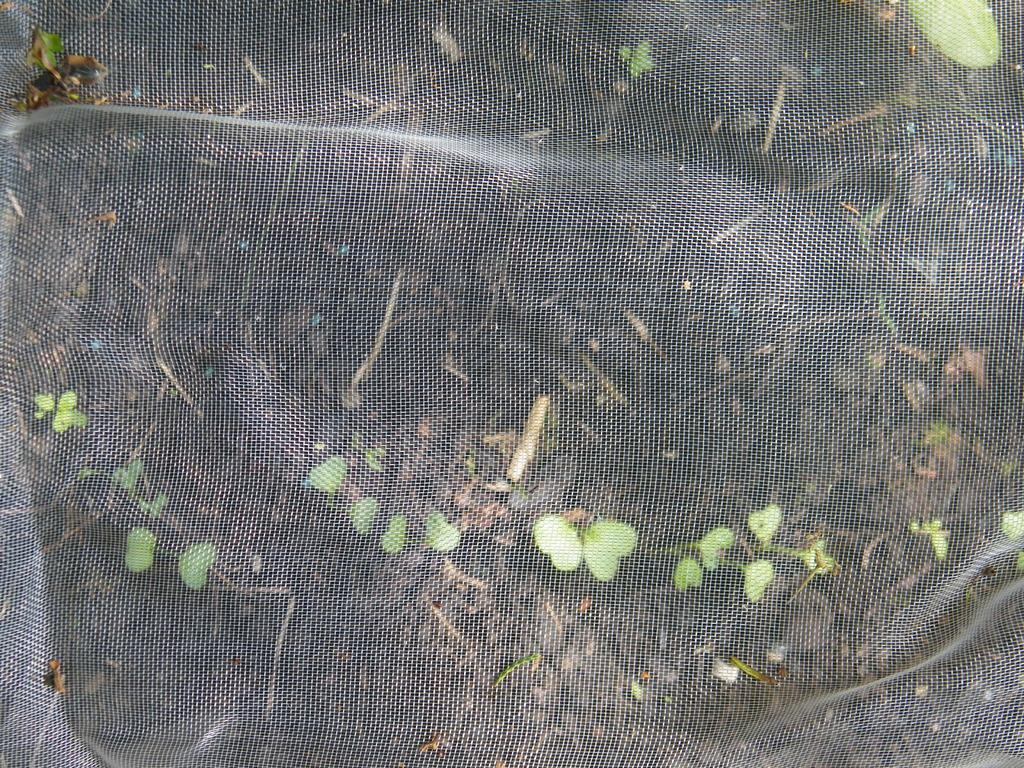What type of living organisms can be seen in the image? Plants can be seen in the image. Where are the plants located in the image? The plants are on the ground in the image. What material is the mesh in the image made of? The mesh in the image is made of metal. What type of lunchroom is visible in the image? There is no lunchroom present in the image. What nation is represented by the plants in the image? The image does not represent any specific nation; it simply shows plants on the ground. 